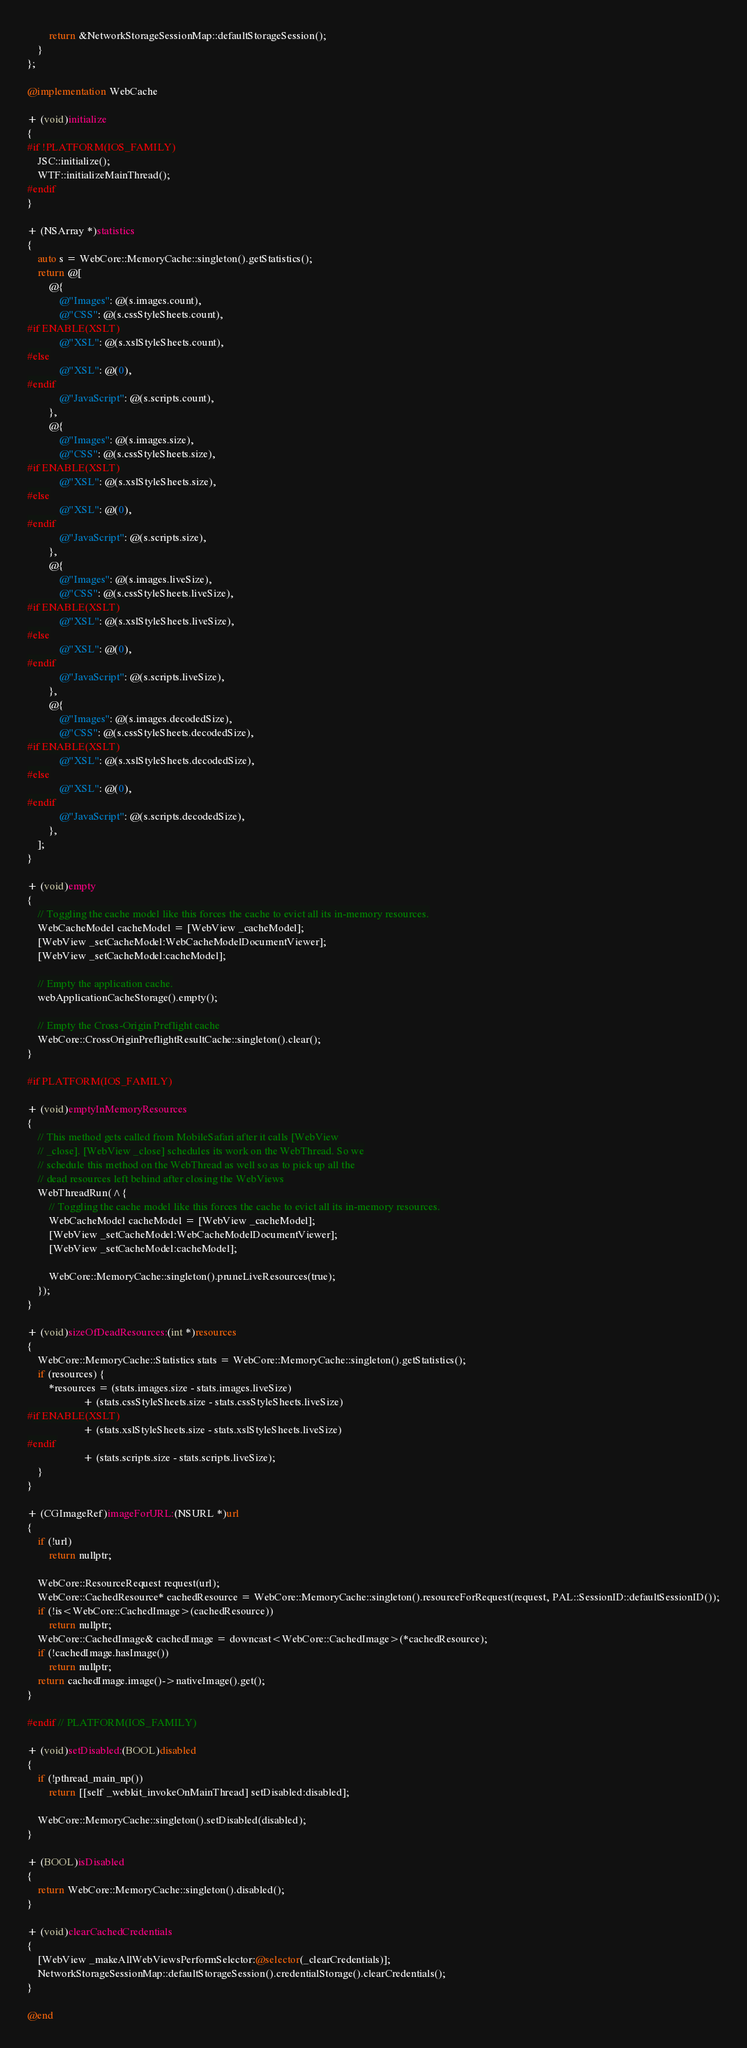<code> <loc_0><loc_0><loc_500><loc_500><_ObjectiveC_>        return &NetworkStorageSessionMap::defaultStorageSession();
    }
};

@implementation WebCache

+ (void)initialize
{
#if !PLATFORM(IOS_FAMILY)
    JSC::initialize();
    WTF::initializeMainThread();
#endif
}

+ (NSArray *)statistics
{
    auto s = WebCore::MemoryCache::singleton().getStatistics();
    return @[
        @{
            @"Images": @(s.images.count),
            @"CSS": @(s.cssStyleSheets.count),
#if ENABLE(XSLT)
            @"XSL": @(s.xslStyleSheets.count),
#else
            @"XSL": @(0),
#endif
            @"JavaScript": @(s.scripts.count),
        },
        @{
            @"Images": @(s.images.size),
            @"CSS": @(s.cssStyleSheets.size),
#if ENABLE(XSLT)
            @"XSL": @(s.xslStyleSheets.size),
#else
            @"XSL": @(0),
#endif
            @"JavaScript": @(s.scripts.size),
        },
        @{
            @"Images": @(s.images.liveSize),
            @"CSS": @(s.cssStyleSheets.liveSize),
#if ENABLE(XSLT)
            @"XSL": @(s.xslStyleSheets.liveSize),
#else
            @"XSL": @(0),
#endif
            @"JavaScript": @(s.scripts.liveSize),
        },
        @{
            @"Images": @(s.images.decodedSize),
            @"CSS": @(s.cssStyleSheets.decodedSize),
#if ENABLE(XSLT)
            @"XSL": @(s.xslStyleSheets.decodedSize),
#else
            @"XSL": @(0),
#endif
            @"JavaScript": @(s.scripts.decodedSize),
        },
    ];
}

+ (void)empty
{
    // Toggling the cache model like this forces the cache to evict all its in-memory resources.
    WebCacheModel cacheModel = [WebView _cacheModel];
    [WebView _setCacheModel:WebCacheModelDocumentViewer];
    [WebView _setCacheModel:cacheModel];

    // Empty the application cache.
    webApplicationCacheStorage().empty();

    // Empty the Cross-Origin Preflight cache
    WebCore::CrossOriginPreflightResultCache::singleton().clear();
}

#if PLATFORM(IOS_FAMILY)

+ (void)emptyInMemoryResources
{
    // This method gets called from MobileSafari after it calls [WebView
    // _close]. [WebView _close] schedules its work on the WebThread. So we
    // schedule this method on the WebThread as well so as to pick up all the
    // dead resources left behind after closing the WebViews
    WebThreadRun(^{
        // Toggling the cache model like this forces the cache to evict all its in-memory resources.
        WebCacheModel cacheModel = [WebView _cacheModel];
        [WebView _setCacheModel:WebCacheModelDocumentViewer];
        [WebView _setCacheModel:cacheModel];

        WebCore::MemoryCache::singleton().pruneLiveResources(true);
    });
}

+ (void)sizeOfDeadResources:(int *)resources
{
    WebCore::MemoryCache::Statistics stats = WebCore::MemoryCache::singleton().getStatistics();
    if (resources) {
        *resources = (stats.images.size - stats.images.liveSize)
                     + (stats.cssStyleSheets.size - stats.cssStyleSheets.liveSize)
#if ENABLE(XSLT)
                     + (stats.xslStyleSheets.size - stats.xslStyleSheets.liveSize)
#endif
                     + (stats.scripts.size - stats.scripts.liveSize);
    }
}

+ (CGImageRef)imageForURL:(NSURL *)url
{
    if (!url)
        return nullptr;
    
    WebCore::ResourceRequest request(url);
    WebCore::CachedResource* cachedResource = WebCore::MemoryCache::singleton().resourceForRequest(request, PAL::SessionID::defaultSessionID());
    if (!is<WebCore::CachedImage>(cachedResource))
        return nullptr;
    WebCore::CachedImage& cachedImage = downcast<WebCore::CachedImage>(*cachedResource);
    if (!cachedImage.hasImage())
        return nullptr;
    return cachedImage.image()->nativeImage().get();
}

#endif // PLATFORM(IOS_FAMILY)

+ (void)setDisabled:(BOOL)disabled
{
    if (!pthread_main_np())
        return [[self _webkit_invokeOnMainThread] setDisabled:disabled];

    WebCore::MemoryCache::singleton().setDisabled(disabled);
}

+ (BOOL)isDisabled
{
    return WebCore::MemoryCache::singleton().disabled();
}

+ (void)clearCachedCredentials
{
    [WebView _makeAllWebViewsPerformSelector:@selector(_clearCredentials)];
    NetworkStorageSessionMap::defaultStorageSession().credentialStorage().clearCredentials();
}

@end
</code> 